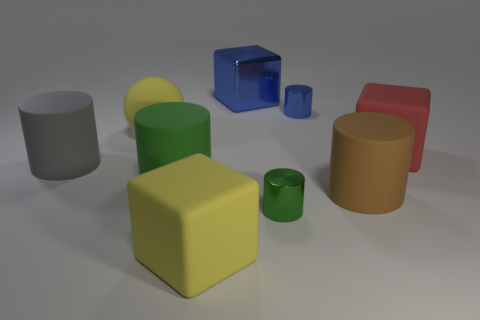Subtract all blue cylinders. How many cylinders are left? 4 Subtract all purple cylinders. Subtract all green cubes. How many cylinders are left? 5 Add 1 small green cylinders. How many objects exist? 10 Subtract all cubes. How many objects are left? 6 Add 5 yellow objects. How many yellow objects are left? 7 Add 5 large yellow rubber objects. How many large yellow rubber objects exist? 7 Subtract 0 cyan cylinders. How many objects are left? 9 Subtract all gray objects. Subtract all large blue metal blocks. How many objects are left? 7 